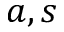<formula> <loc_0><loc_0><loc_500><loc_500>a , s</formula> 